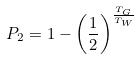<formula> <loc_0><loc_0><loc_500><loc_500>P _ { 2 } = 1 - \left ( \frac { 1 } { 2 } \right ) ^ { \frac { T _ { G } } { T _ { W } } }</formula> 